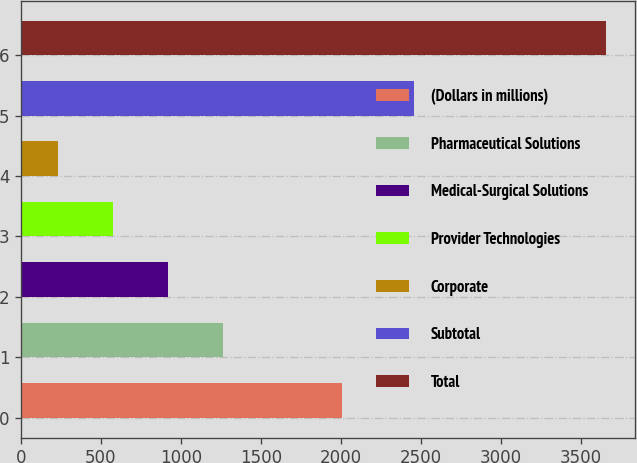Convert chart to OTSL. <chart><loc_0><loc_0><loc_500><loc_500><bar_chart><fcel>(Dollars in millions)<fcel>Pharmaceutical Solutions<fcel>Medical-Surgical Solutions<fcel>Provider Technologies<fcel>Corporate<fcel>Subtotal<fcel>Total<nl><fcel>2005<fcel>1260.43<fcel>918.32<fcel>576.21<fcel>234.1<fcel>2455.2<fcel>3655.2<nl></chart> 